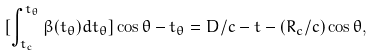Convert formula to latex. <formula><loc_0><loc_0><loc_500><loc_500>[ \int _ { t _ { c } } ^ { t _ { \theta } } \beta ( t _ { \theta } ) d t _ { \theta } ] \cos \theta - t _ { \theta } = D / c - t - ( R _ { c } / c ) \cos \theta ,</formula> 